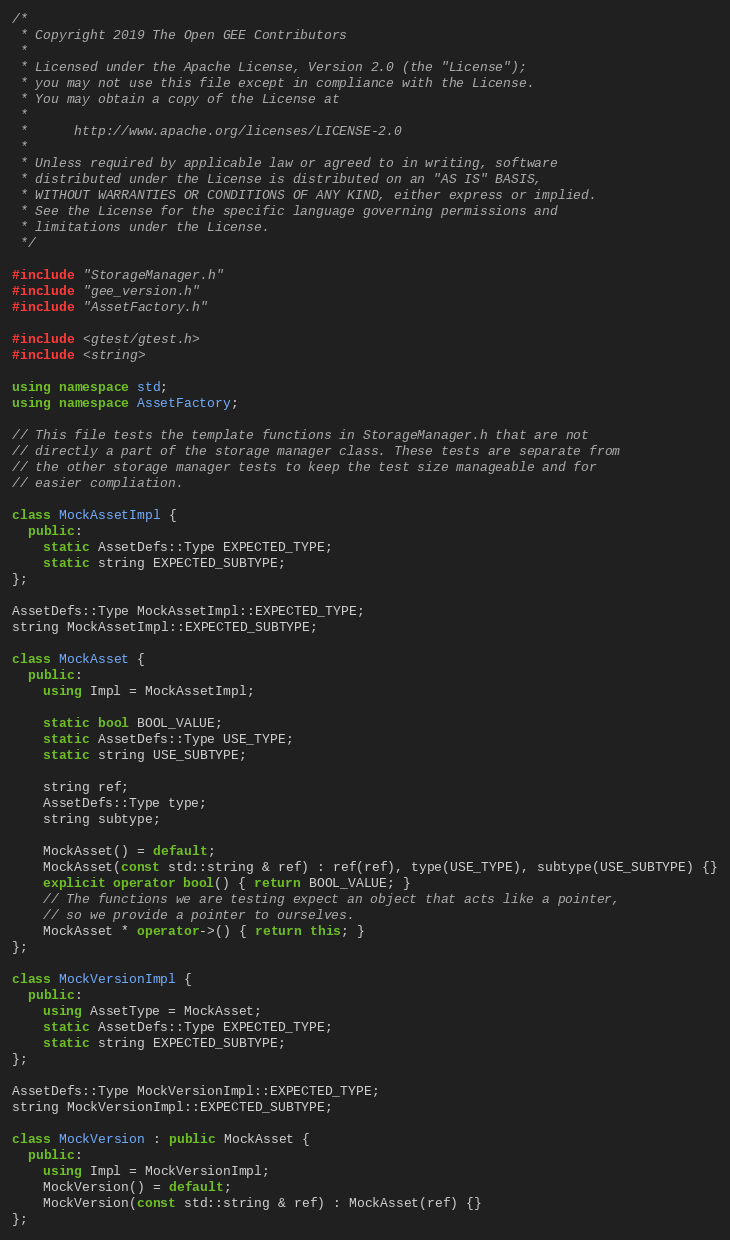<code> <loc_0><loc_0><loc_500><loc_500><_C++_>/*
 * Copyright 2019 The Open GEE Contributors
 *
 * Licensed under the Apache License, Version 2.0 (the "License");
 * you may not use this file except in compliance with the License.
 * You may obtain a copy of the License at
 *
 *      http://www.apache.org/licenses/LICENSE-2.0
 *
 * Unless required by applicable law or agreed to in writing, software
 * distributed under the License is distributed on an "AS IS" BASIS,
 * WITHOUT WARRANTIES OR CONDITIONS OF ANY KIND, either express or implied.
 * See the License for the specific language governing permissions and
 * limitations under the License.
 */

#include "StorageManager.h"
#include "gee_version.h"
#include "AssetFactory.h"

#include <gtest/gtest.h>
#include <string>

using namespace std;
using namespace AssetFactory;

// This file tests the template functions in StorageManager.h that are not
// directly a part of the storage manager class. These tests are separate from
// the other storage manager tests to keep the test size manageable and for
// easier compliation.

class MockAssetImpl {
  public:
    static AssetDefs::Type EXPECTED_TYPE;
    static string EXPECTED_SUBTYPE;
};

AssetDefs::Type MockAssetImpl::EXPECTED_TYPE;
string MockAssetImpl::EXPECTED_SUBTYPE;

class MockAsset {
  public:
    using Impl = MockAssetImpl;

    static bool BOOL_VALUE;
    static AssetDefs::Type USE_TYPE;
    static string USE_SUBTYPE;
    
    string ref;
    AssetDefs::Type type;
    string subtype;

    MockAsset() = default;
    MockAsset(const std::string & ref) : ref(ref), type(USE_TYPE), subtype(USE_SUBTYPE) {}
    explicit operator bool() { return BOOL_VALUE; }
    // The functions we are testing expect an object that acts like a pointer,
    // so we provide a pointer to ourselves.
    MockAsset * operator->() { return this; }
};

class MockVersionImpl {
  public:
    using AssetType = MockAsset;
    static AssetDefs::Type EXPECTED_TYPE;
    static string EXPECTED_SUBTYPE;
};

AssetDefs::Type MockVersionImpl::EXPECTED_TYPE;
string MockVersionImpl::EXPECTED_SUBTYPE;

class MockVersion : public MockAsset {
  public:
    using Impl = MockVersionImpl;
    MockVersion() = default;
    MockVersion(const std::string & ref) : MockAsset(ref) {}
};
</code> 